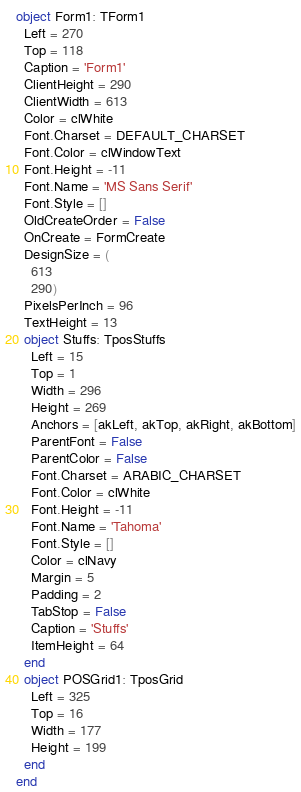<code> <loc_0><loc_0><loc_500><loc_500><_Pascal_>object Form1: TForm1
  Left = 270
  Top = 118
  Caption = 'Form1'
  ClientHeight = 290
  ClientWidth = 613
  Color = clWhite
  Font.Charset = DEFAULT_CHARSET
  Font.Color = clWindowText
  Font.Height = -11
  Font.Name = 'MS Sans Serif'
  Font.Style = []
  OldCreateOrder = False
  OnCreate = FormCreate
  DesignSize = (
    613
    290)
  PixelsPerInch = 96
  TextHeight = 13
  object Stuffs: TposStuffs
    Left = 15
    Top = 1
    Width = 296
    Height = 269
    Anchors = [akLeft, akTop, akRight, akBottom]
    ParentFont = False
    ParentColor = False
    Font.Charset = ARABIC_CHARSET
    Font.Color = clWhite
    Font.Height = -11
    Font.Name = 'Tahoma'
    Font.Style = []
    Color = clNavy
    Margin = 5
    Padding = 2
    TabStop = False
    Caption = 'Stuffs'
    ItemHeight = 64
  end
  object POSGrid1: TposGrid
    Left = 325
    Top = 16
    Width = 177
    Height = 199
  end
end
</code> 